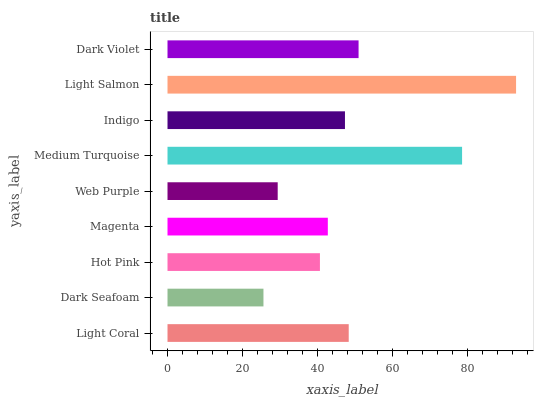Is Dark Seafoam the minimum?
Answer yes or no. Yes. Is Light Salmon the maximum?
Answer yes or no. Yes. Is Hot Pink the minimum?
Answer yes or no. No. Is Hot Pink the maximum?
Answer yes or no. No. Is Hot Pink greater than Dark Seafoam?
Answer yes or no. Yes. Is Dark Seafoam less than Hot Pink?
Answer yes or no. Yes. Is Dark Seafoam greater than Hot Pink?
Answer yes or no. No. Is Hot Pink less than Dark Seafoam?
Answer yes or no. No. Is Indigo the high median?
Answer yes or no. Yes. Is Indigo the low median?
Answer yes or no. Yes. Is Magenta the high median?
Answer yes or no. No. Is Medium Turquoise the low median?
Answer yes or no. No. 